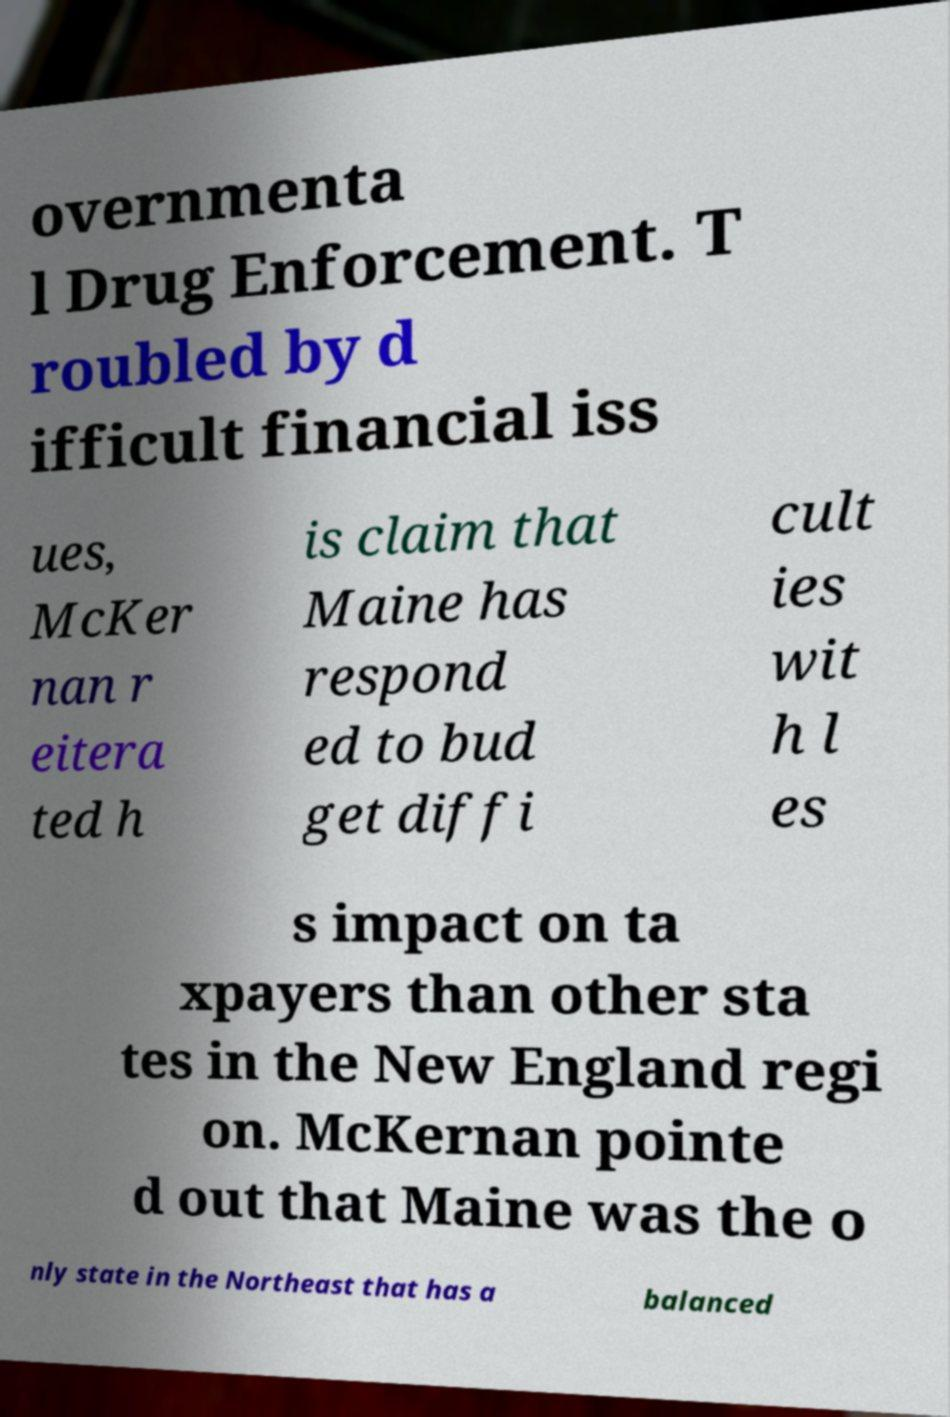Please identify and transcribe the text found in this image. overnmenta l Drug Enforcement. T roubled by d ifficult financial iss ues, McKer nan r eitera ted h is claim that Maine has respond ed to bud get diffi cult ies wit h l es s impact on ta xpayers than other sta tes in the New England regi on. McKernan pointe d out that Maine was the o nly state in the Northeast that has a balanced 